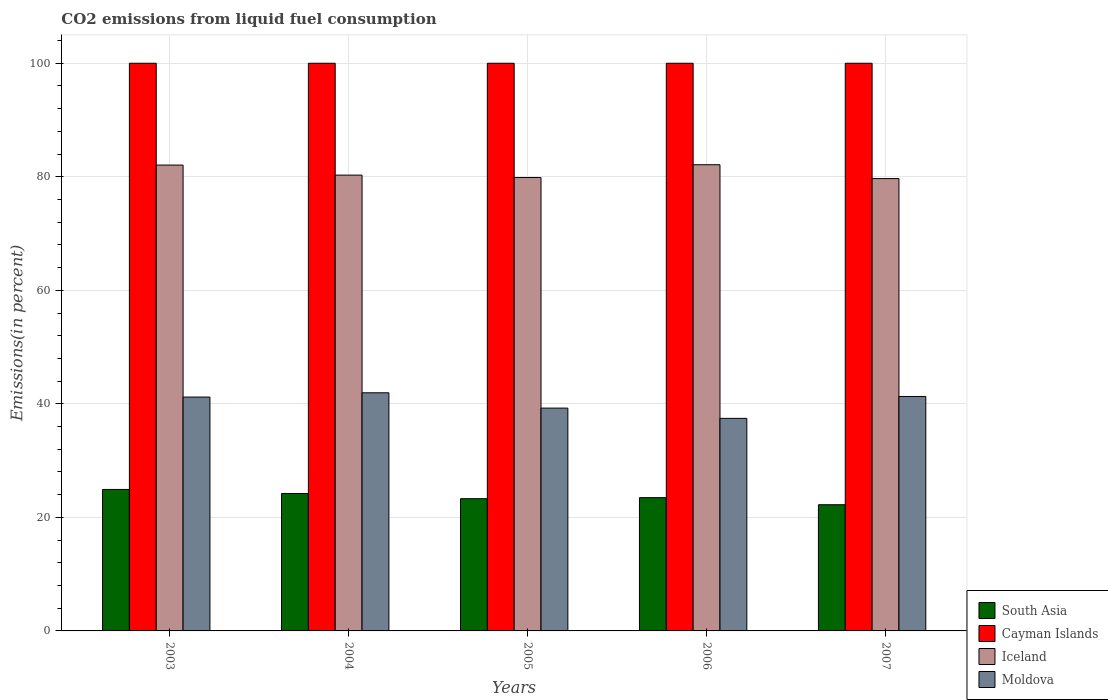Are the number of bars per tick equal to the number of legend labels?
Offer a very short reply. Yes. Are the number of bars on each tick of the X-axis equal?
Make the answer very short. Yes. How many bars are there on the 5th tick from the right?
Offer a terse response. 4. What is the label of the 2nd group of bars from the left?
Provide a short and direct response. 2004. In how many cases, is the number of bars for a given year not equal to the number of legend labels?
Ensure brevity in your answer.  0. What is the total CO2 emitted in South Asia in 2007?
Give a very brief answer. 22.23. Across all years, what is the maximum total CO2 emitted in South Asia?
Provide a short and direct response. 24.92. Across all years, what is the minimum total CO2 emitted in Iceland?
Provide a short and direct response. 79.68. In which year was the total CO2 emitted in Iceland minimum?
Provide a succinct answer. 2007. What is the total total CO2 emitted in Cayman Islands in the graph?
Your answer should be compact. 500. What is the difference between the total CO2 emitted in Moldova in 2005 and that in 2006?
Provide a succinct answer. 1.81. What is the difference between the total CO2 emitted in South Asia in 2005 and the total CO2 emitted in Cayman Islands in 2006?
Provide a succinct answer. -76.71. What is the average total CO2 emitted in Iceland per year?
Your response must be concise. 80.81. In the year 2003, what is the difference between the total CO2 emitted in South Asia and total CO2 emitted in Moldova?
Provide a short and direct response. -16.27. In how many years, is the total CO2 emitted in Iceland greater than 32 %?
Give a very brief answer. 5. What is the ratio of the total CO2 emitted in Moldova in 2003 to that in 2004?
Give a very brief answer. 0.98. What is the difference between the highest and the second highest total CO2 emitted in Moldova?
Ensure brevity in your answer.  0.65. What is the difference between the highest and the lowest total CO2 emitted in Iceland?
Your response must be concise. 2.44. In how many years, is the total CO2 emitted in South Asia greater than the average total CO2 emitted in South Asia taken over all years?
Your answer should be very brief. 2. What does the 3rd bar from the left in 2003 represents?
Your answer should be very brief. Iceland. Is it the case that in every year, the sum of the total CO2 emitted in Moldova and total CO2 emitted in South Asia is greater than the total CO2 emitted in Iceland?
Ensure brevity in your answer.  No. How many bars are there?
Your answer should be compact. 20. Are all the bars in the graph horizontal?
Offer a very short reply. No. What is the difference between two consecutive major ticks on the Y-axis?
Your answer should be very brief. 20. Are the values on the major ticks of Y-axis written in scientific E-notation?
Your response must be concise. No. Where does the legend appear in the graph?
Your answer should be very brief. Bottom right. What is the title of the graph?
Your answer should be compact. CO2 emissions from liquid fuel consumption. Does "Congo (Republic)" appear as one of the legend labels in the graph?
Ensure brevity in your answer.  No. What is the label or title of the Y-axis?
Provide a succinct answer. Emissions(in percent). What is the Emissions(in percent) in South Asia in 2003?
Provide a succinct answer. 24.92. What is the Emissions(in percent) in Cayman Islands in 2003?
Offer a terse response. 100. What is the Emissions(in percent) in Iceland in 2003?
Your answer should be very brief. 82.06. What is the Emissions(in percent) of Moldova in 2003?
Your response must be concise. 41.2. What is the Emissions(in percent) in South Asia in 2004?
Offer a terse response. 24.21. What is the Emissions(in percent) of Cayman Islands in 2004?
Your answer should be very brief. 100. What is the Emissions(in percent) in Iceland in 2004?
Offer a terse response. 80.3. What is the Emissions(in percent) in Moldova in 2004?
Make the answer very short. 41.95. What is the Emissions(in percent) in South Asia in 2005?
Your response must be concise. 23.29. What is the Emissions(in percent) of Iceland in 2005?
Ensure brevity in your answer.  79.87. What is the Emissions(in percent) in Moldova in 2005?
Ensure brevity in your answer.  39.25. What is the Emissions(in percent) of South Asia in 2006?
Provide a succinct answer. 23.48. What is the Emissions(in percent) in Cayman Islands in 2006?
Make the answer very short. 100. What is the Emissions(in percent) in Iceland in 2006?
Make the answer very short. 82.13. What is the Emissions(in percent) in Moldova in 2006?
Your response must be concise. 37.44. What is the Emissions(in percent) in South Asia in 2007?
Offer a terse response. 22.23. What is the Emissions(in percent) in Iceland in 2007?
Make the answer very short. 79.68. What is the Emissions(in percent) in Moldova in 2007?
Keep it short and to the point. 41.3. Across all years, what is the maximum Emissions(in percent) in South Asia?
Ensure brevity in your answer.  24.92. Across all years, what is the maximum Emissions(in percent) of Cayman Islands?
Provide a short and direct response. 100. Across all years, what is the maximum Emissions(in percent) of Iceland?
Offer a very short reply. 82.13. Across all years, what is the maximum Emissions(in percent) of Moldova?
Give a very brief answer. 41.95. Across all years, what is the minimum Emissions(in percent) of South Asia?
Make the answer very short. 22.23. Across all years, what is the minimum Emissions(in percent) of Iceland?
Give a very brief answer. 79.68. Across all years, what is the minimum Emissions(in percent) in Moldova?
Your answer should be compact. 37.44. What is the total Emissions(in percent) in South Asia in the graph?
Provide a succinct answer. 118.14. What is the total Emissions(in percent) of Cayman Islands in the graph?
Ensure brevity in your answer.  500. What is the total Emissions(in percent) of Iceland in the graph?
Provide a short and direct response. 404.03. What is the total Emissions(in percent) in Moldova in the graph?
Make the answer very short. 201.14. What is the difference between the Emissions(in percent) in South Asia in 2003 and that in 2004?
Make the answer very short. 0.71. What is the difference between the Emissions(in percent) in Iceland in 2003 and that in 2004?
Provide a short and direct response. 1.77. What is the difference between the Emissions(in percent) of Moldova in 2003 and that in 2004?
Your response must be concise. -0.75. What is the difference between the Emissions(in percent) in South Asia in 2003 and that in 2005?
Keep it short and to the point. 1.63. What is the difference between the Emissions(in percent) in Cayman Islands in 2003 and that in 2005?
Keep it short and to the point. 0. What is the difference between the Emissions(in percent) in Iceland in 2003 and that in 2005?
Offer a terse response. 2.2. What is the difference between the Emissions(in percent) of Moldova in 2003 and that in 2005?
Offer a very short reply. 1.95. What is the difference between the Emissions(in percent) in South Asia in 2003 and that in 2006?
Keep it short and to the point. 1.44. What is the difference between the Emissions(in percent) of Iceland in 2003 and that in 2006?
Offer a terse response. -0.06. What is the difference between the Emissions(in percent) in Moldova in 2003 and that in 2006?
Your response must be concise. 3.75. What is the difference between the Emissions(in percent) in South Asia in 2003 and that in 2007?
Provide a short and direct response. 2.69. What is the difference between the Emissions(in percent) of Iceland in 2003 and that in 2007?
Give a very brief answer. 2.38. What is the difference between the Emissions(in percent) of Moldova in 2003 and that in 2007?
Make the answer very short. -0.1. What is the difference between the Emissions(in percent) of South Asia in 2004 and that in 2005?
Provide a succinct answer. 0.92. What is the difference between the Emissions(in percent) in Cayman Islands in 2004 and that in 2005?
Offer a very short reply. 0. What is the difference between the Emissions(in percent) in Iceland in 2004 and that in 2005?
Provide a short and direct response. 0.43. What is the difference between the Emissions(in percent) of Moldova in 2004 and that in 2005?
Provide a short and direct response. 2.7. What is the difference between the Emissions(in percent) of South Asia in 2004 and that in 2006?
Your response must be concise. 0.73. What is the difference between the Emissions(in percent) in Cayman Islands in 2004 and that in 2006?
Keep it short and to the point. 0. What is the difference between the Emissions(in percent) in Iceland in 2004 and that in 2006?
Make the answer very short. -1.83. What is the difference between the Emissions(in percent) of Moldova in 2004 and that in 2006?
Your response must be concise. 4.5. What is the difference between the Emissions(in percent) of South Asia in 2004 and that in 2007?
Keep it short and to the point. 1.98. What is the difference between the Emissions(in percent) of Iceland in 2004 and that in 2007?
Give a very brief answer. 0.61. What is the difference between the Emissions(in percent) of Moldova in 2004 and that in 2007?
Your response must be concise. 0.65. What is the difference between the Emissions(in percent) in South Asia in 2005 and that in 2006?
Provide a short and direct response. -0.18. What is the difference between the Emissions(in percent) of Iceland in 2005 and that in 2006?
Provide a succinct answer. -2.26. What is the difference between the Emissions(in percent) of Moldova in 2005 and that in 2006?
Make the answer very short. 1.81. What is the difference between the Emissions(in percent) in South Asia in 2005 and that in 2007?
Provide a succinct answer. 1.06. What is the difference between the Emissions(in percent) in Cayman Islands in 2005 and that in 2007?
Make the answer very short. 0. What is the difference between the Emissions(in percent) of Iceland in 2005 and that in 2007?
Your answer should be compact. 0.18. What is the difference between the Emissions(in percent) of Moldova in 2005 and that in 2007?
Your answer should be compact. -2.05. What is the difference between the Emissions(in percent) in South Asia in 2006 and that in 2007?
Offer a very short reply. 1.25. What is the difference between the Emissions(in percent) of Iceland in 2006 and that in 2007?
Keep it short and to the point. 2.44. What is the difference between the Emissions(in percent) in Moldova in 2006 and that in 2007?
Your answer should be compact. -3.86. What is the difference between the Emissions(in percent) of South Asia in 2003 and the Emissions(in percent) of Cayman Islands in 2004?
Your response must be concise. -75.08. What is the difference between the Emissions(in percent) of South Asia in 2003 and the Emissions(in percent) of Iceland in 2004?
Offer a terse response. -55.37. What is the difference between the Emissions(in percent) in South Asia in 2003 and the Emissions(in percent) in Moldova in 2004?
Make the answer very short. -17.03. What is the difference between the Emissions(in percent) of Cayman Islands in 2003 and the Emissions(in percent) of Iceland in 2004?
Give a very brief answer. 19.7. What is the difference between the Emissions(in percent) of Cayman Islands in 2003 and the Emissions(in percent) of Moldova in 2004?
Your answer should be very brief. 58.05. What is the difference between the Emissions(in percent) of Iceland in 2003 and the Emissions(in percent) of Moldova in 2004?
Provide a succinct answer. 40.12. What is the difference between the Emissions(in percent) in South Asia in 2003 and the Emissions(in percent) in Cayman Islands in 2005?
Give a very brief answer. -75.08. What is the difference between the Emissions(in percent) of South Asia in 2003 and the Emissions(in percent) of Iceland in 2005?
Keep it short and to the point. -54.94. What is the difference between the Emissions(in percent) in South Asia in 2003 and the Emissions(in percent) in Moldova in 2005?
Provide a succinct answer. -14.33. What is the difference between the Emissions(in percent) in Cayman Islands in 2003 and the Emissions(in percent) in Iceland in 2005?
Offer a terse response. 20.13. What is the difference between the Emissions(in percent) of Cayman Islands in 2003 and the Emissions(in percent) of Moldova in 2005?
Your answer should be compact. 60.75. What is the difference between the Emissions(in percent) in Iceland in 2003 and the Emissions(in percent) in Moldova in 2005?
Provide a succinct answer. 42.81. What is the difference between the Emissions(in percent) in South Asia in 2003 and the Emissions(in percent) in Cayman Islands in 2006?
Ensure brevity in your answer.  -75.08. What is the difference between the Emissions(in percent) in South Asia in 2003 and the Emissions(in percent) in Iceland in 2006?
Ensure brevity in your answer.  -57.2. What is the difference between the Emissions(in percent) of South Asia in 2003 and the Emissions(in percent) of Moldova in 2006?
Your answer should be compact. -12.52. What is the difference between the Emissions(in percent) in Cayman Islands in 2003 and the Emissions(in percent) in Iceland in 2006?
Your answer should be compact. 17.87. What is the difference between the Emissions(in percent) in Cayman Islands in 2003 and the Emissions(in percent) in Moldova in 2006?
Offer a terse response. 62.56. What is the difference between the Emissions(in percent) in Iceland in 2003 and the Emissions(in percent) in Moldova in 2006?
Ensure brevity in your answer.  44.62. What is the difference between the Emissions(in percent) of South Asia in 2003 and the Emissions(in percent) of Cayman Islands in 2007?
Your answer should be very brief. -75.08. What is the difference between the Emissions(in percent) of South Asia in 2003 and the Emissions(in percent) of Iceland in 2007?
Offer a very short reply. -54.76. What is the difference between the Emissions(in percent) in South Asia in 2003 and the Emissions(in percent) in Moldova in 2007?
Offer a terse response. -16.38. What is the difference between the Emissions(in percent) of Cayman Islands in 2003 and the Emissions(in percent) of Iceland in 2007?
Your response must be concise. 20.32. What is the difference between the Emissions(in percent) of Cayman Islands in 2003 and the Emissions(in percent) of Moldova in 2007?
Your response must be concise. 58.7. What is the difference between the Emissions(in percent) of Iceland in 2003 and the Emissions(in percent) of Moldova in 2007?
Your response must be concise. 40.76. What is the difference between the Emissions(in percent) of South Asia in 2004 and the Emissions(in percent) of Cayman Islands in 2005?
Offer a very short reply. -75.79. What is the difference between the Emissions(in percent) in South Asia in 2004 and the Emissions(in percent) in Iceland in 2005?
Ensure brevity in your answer.  -55.65. What is the difference between the Emissions(in percent) of South Asia in 2004 and the Emissions(in percent) of Moldova in 2005?
Provide a short and direct response. -15.04. What is the difference between the Emissions(in percent) of Cayman Islands in 2004 and the Emissions(in percent) of Iceland in 2005?
Offer a terse response. 20.13. What is the difference between the Emissions(in percent) of Cayman Islands in 2004 and the Emissions(in percent) of Moldova in 2005?
Offer a terse response. 60.75. What is the difference between the Emissions(in percent) in Iceland in 2004 and the Emissions(in percent) in Moldova in 2005?
Your answer should be compact. 41.04. What is the difference between the Emissions(in percent) of South Asia in 2004 and the Emissions(in percent) of Cayman Islands in 2006?
Provide a succinct answer. -75.79. What is the difference between the Emissions(in percent) in South Asia in 2004 and the Emissions(in percent) in Iceland in 2006?
Provide a short and direct response. -57.91. What is the difference between the Emissions(in percent) of South Asia in 2004 and the Emissions(in percent) of Moldova in 2006?
Provide a short and direct response. -13.23. What is the difference between the Emissions(in percent) in Cayman Islands in 2004 and the Emissions(in percent) in Iceland in 2006?
Provide a succinct answer. 17.87. What is the difference between the Emissions(in percent) of Cayman Islands in 2004 and the Emissions(in percent) of Moldova in 2006?
Keep it short and to the point. 62.56. What is the difference between the Emissions(in percent) in Iceland in 2004 and the Emissions(in percent) in Moldova in 2006?
Give a very brief answer. 42.85. What is the difference between the Emissions(in percent) in South Asia in 2004 and the Emissions(in percent) in Cayman Islands in 2007?
Your answer should be very brief. -75.79. What is the difference between the Emissions(in percent) in South Asia in 2004 and the Emissions(in percent) in Iceland in 2007?
Offer a terse response. -55.47. What is the difference between the Emissions(in percent) of South Asia in 2004 and the Emissions(in percent) of Moldova in 2007?
Make the answer very short. -17.09. What is the difference between the Emissions(in percent) of Cayman Islands in 2004 and the Emissions(in percent) of Iceland in 2007?
Ensure brevity in your answer.  20.32. What is the difference between the Emissions(in percent) of Cayman Islands in 2004 and the Emissions(in percent) of Moldova in 2007?
Provide a short and direct response. 58.7. What is the difference between the Emissions(in percent) in Iceland in 2004 and the Emissions(in percent) in Moldova in 2007?
Your answer should be very brief. 38.99. What is the difference between the Emissions(in percent) of South Asia in 2005 and the Emissions(in percent) of Cayman Islands in 2006?
Give a very brief answer. -76.71. What is the difference between the Emissions(in percent) in South Asia in 2005 and the Emissions(in percent) in Iceland in 2006?
Offer a very short reply. -58.83. What is the difference between the Emissions(in percent) of South Asia in 2005 and the Emissions(in percent) of Moldova in 2006?
Offer a very short reply. -14.15. What is the difference between the Emissions(in percent) in Cayman Islands in 2005 and the Emissions(in percent) in Iceland in 2006?
Ensure brevity in your answer.  17.87. What is the difference between the Emissions(in percent) of Cayman Islands in 2005 and the Emissions(in percent) of Moldova in 2006?
Give a very brief answer. 62.56. What is the difference between the Emissions(in percent) in Iceland in 2005 and the Emissions(in percent) in Moldova in 2006?
Make the answer very short. 42.42. What is the difference between the Emissions(in percent) of South Asia in 2005 and the Emissions(in percent) of Cayman Islands in 2007?
Ensure brevity in your answer.  -76.71. What is the difference between the Emissions(in percent) in South Asia in 2005 and the Emissions(in percent) in Iceland in 2007?
Offer a terse response. -56.39. What is the difference between the Emissions(in percent) of South Asia in 2005 and the Emissions(in percent) of Moldova in 2007?
Keep it short and to the point. -18.01. What is the difference between the Emissions(in percent) in Cayman Islands in 2005 and the Emissions(in percent) in Iceland in 2007?
Keep it short and to the point. 20.32. What is the difference between the Emissions(in percent) of Cayman Islands in 2005 and the Emissions(in percent) of Moldova in 2007?
Your answer should be very brief. 58.7. What is the difference between the Emissions(in percent) in Iceland in 2005 and the Emissions(in percent) in Moldova in 2007?
Your answer should be compact. 38.57. What is the difference between the Emissions(in percent) of South Asia in 2006 and the Emissions(in percent) of Cayman Islands in 2007?
Your response must be concise. -76.52. What is the difference between the Emissions(in percent) in South Asia in 2006 and the Emissions(in percent) in Iceland in 2007?
Provide a short and direct response. -56.2. What is the difference between the Emissions(in percent) in South Asia in 2006 and the Emissions(in percent) in Moldova in 2007?
Your answer should be very brief. -17.82. What is the difference between the Emissions(in percent) of Cayman Islands in 2006 and the Emissions(in percent) of Iceland in 2007?
Keep it short and to the point. 20.32. What is the difference between the Emissions(in percent) of Cayman Islands in 2006 and the Emissions(in percent) of Moldova in 2007?
Offer a very short reply. 58.7. What is the difference between the Emissions(in percent) of Iceland in 2006 and the Emissions(in percent) of Moldova in 2007?
Your answer should be compact. 40.82. What is the average Emissions(in percent) in South Asia per year?
Make the answer very short. 23.63. What is the average Emissions(in percent) in Iceland per year?
Offer a terse response. 80.81. What is the average Emissions(in percent) of Moldova per year?
Your answer should be very brief. 40.23. In the year 2003, what is the difference between the Emissions(in percent) of South Asia and Emissions(in percent) of Cayman Islands?
Provide a short and direct response. -75.08. In the year 2003, what is the difference between the Emissions(in percent) of South Asia and Emissions(in percent) of Iceland?
Your response must be concise. -57.14. In the year 2003, what is the difference between the Emissions(in percent) of South Asia and Emissions(in percent) of Moldova?
Offer a very short reply. -16.27. In the year 2003, what is the difference between the Emissions(in percent) in Cayman Islands and Emissions(in percent) in Iceland?
Offer a very short reply. 17.94. In the year 2003, what is the difference between the Emissions(in percent) in Cayman Islands and Emissions(in percent) in Moldova?
Give a very brief answer. 58.8. In the year 2003, what is the difference between the Emissions(in percent) in Iceland and Emissions(in percent) in Moldova?
Make the answer very short. 40.87. In the year 2004, what is the difference between the Emissions(in percent) of South Asia and Emissions(in percent) of Cayman Islands?
Provide a succinct answer. -75.79. In the year 2004, what is the difference between the Emissions(in percent) in South Asia and Emissions(in percent) in Iceland?
Ensure brevity in your answer.  -56.08. In the year 2004, what is the difference between the Emissions(in percent) in South Asia and Emissions(in percent) in Moldova?
Keep it short and to the point. -17.74. In the year 2004, what is the difference between the Emissions(in percent) in Cayman Islands and Emissions(in percent) in Iceland?
Provide a succinct answer. 19.7. In the year 2004, what is the difference between the Emissions(in percent) of Cayman Islands and Emissions(in percent) of Moldova?
Your answer should be very brief. 58.05. In the year 2004, what is the difference between the Emissions(in percent) of Iceland and Emissions(in percent) of Moldova?
Provide a succinct answer. 38.35. In the year 2005, what is the difference between the Emissions(in percent) of South Asia and Emissions(in percent) of Cayman Islands?
Your answer should be compact. -76.71. In the year 2005, what is the difference between the Emissions(in percent) in South Asia and Emissions(in percent) in Iceland?
Your answer should be very brief. -56.57. In the year 2005, what is the difference between the Emissions(in percent) of South Asia and Emissions(in percent) of Moldova?
Your answer should be very brief. -15.96. In the year 2005, what is the difference between the Emissions(in percent) of Cayman Islands and Emissions(in percent) of Iceland?
Your response must be concise. 20.13. In the year 2005, what is the difference between the Emissions(in percent) of Cayman Islands and Emissions(in percent) of Moldova?
Your answer should be compact. 60.75. In the year 2005, what is the difference between the Emissions(in percent) of Iceland and Emissions(in percent) of Moldova?
Keep it short and to the point. 40.62. In the year 2006, what is the difference between the Emissions(in percent) of South Asia and Emissions(in percent) of Cayman Islands?
Offer a very short reply. -76.52. In the year 2006, what is the difference between the Emissions(in percent) of South Asia and Emissions(in percent) of Iceland?
Provide a succinct answer. -58.65. In the year 2006, what is the difference between the Emissions(in percent) in South Asia and Emissions(in percent) in Moldova?
Provide a succinct answer. -13.97. In the year 2006, what is the difference between the Emissions(in percent) in Cayman Islands and Emissions(in percent) in Iceland?
Provide a short and direct response. 17.87. In the year 2006, what is the difference between the Emissions(in percent) of Cayman Islands and Emissions(in percent) of Moldova?
Your response must be concise. 62.56. In the year 2006, what is the difference between the Emissions(in percent) of Iceland and Emissions(in percent) of Moldova?
Make the answer very short. 44.68. In the year 2007, what is the difference between the Emissions(in percent) of South Asia and Emissions(in percent) of Cayman Islands?
Provide a succinct answer. -77.77. In the year 2007, what is the difference between the Emissions(in percent) of South Asia and Emissions(in percent) of Iceland?
Offer a very short reply. -57.45. In the year 2007, what is the difference between the Emissions(in percent) in South Asia and Emissions(in percent) in Moldova?
Keep it short and to the point. -19.07. In the year 2007, what is the difference between the Emissions(in percent) in Cayman Islands and Emissions(in percent) in Iceland?
Give a very brief answer. 20.32. In the year 2007, what is the difference between the Emissions(in percent) of Cayman Islands and Emissions(in percent) of Moldova?
Provide a short and direct response. 58.7. In the year 2007, what is the difference between the Emissions(in percent) in Iceland and Emissions(in percent) in Moldova?
Your answer should be compact. 38.38. What is the ratio of the Emissions(in percent) of South Asia in 2003 to that in 2004?
Your answer should be very brief. 1.03. What is the ratio of the Emissions(in percent) of Iceland in 2003 to that in 2004?
Your answer should be compact. 1.02. What is the ratio of the Emissions(in percent) of Moldova in 2003 to that in 2004?
Keep it short and to the point. 0.98. What is the ratio of the Emissions(in percent) in South Asia in 2003 to that in 2005?
Ensure brevity in your answer.  1.07. What is the ratio of the Emissions(in percent) in Iceland in 2003 to that in 2005?
Your answer should be very brief. 1.03. What is the ratio of the Emissions(in percent) of Moldova in 2003 to that in 2005?
Keep it short and to the point. 1.05. What is the ratio of the Emissions(in percent) of South Asia in 2003 to that in 2006?
Provide a succinct answer. 1.06. What is the ratio of the Emissions(in percent) of Cayman Islands in 2003 to that in 2006?
Your response must be concise. 1. What is the ratio of the Emissions(in percent) in Moldova in 2003 to that in 2006?
Make the answer very short. 1.1. What is the ratio of the Emissions(in percent) of South Asia in 2003 to that in 2007?
Offer a very short reply. 1.12. What is the ratio of the Emissions(in percent) of Cayman Islands in 2003 to that in 2007?
Ensure brevity in your answer.  1. What is the ratio of the Emissions(in percent) of Iceland in 2003 to that in 2007?
Your answer should be very brief. 1.03. What is the ratio of the Emissions(in percent) of South Asia in 2004 to that in 2005?
Ensure brevity in your answer.  1.04. What is the ratio of the Emissions(in percent) of Iceland in 2004 to that in 2005?
Give a very brief answer. 1.01. What is the ratio of the Emissions(in percent) in Moldova in 2004 to that in 2005?
Give a very brief answer. 1.07. What is the ratio of the Emissions(in percent) of South Asia in 2004 to that in 2006?
Ensure brevity in your answer.  1.03. What is the ratio of the Emissions(in percent) in Cayman Islands in 2004 to that in 2006?
Provide a succinct answer. 1. What is the ratio of the Emissions(in percent) in Iceland in 2004 to that in 2006?
Offer a terse response. 0.98. What is the ratio of the Emissions(in percent) of Moldova in 2004 to that in 2006?
Offer a very short reply. 1.12. What is the ratio of the Emissions(in percent) in South Asia in 2004 to that in 2007?
Your response must be concise. 1.09. What is the ratio of the Emissions(in percent) of Iceland in 2004 to that in 2007?
Your response must be concise. 1.01. What is the ratio of the Emissions(in percent) in Moldova in 2004 to that in 2007?
Ensure brevity in your answer.  1.02. What is the ratio of the Emissions(in percent) of Iceland in 2005 to that in 2006?
Keep it short and to the point. 0.97. What is the ratio of the Emissions(in percent) of Moldova in 2005 to that in 2006?
Provide a succinct answer. 1.05. What is the ratio of the Emissions(in percent) in South Asia in 2005 to that in 2007?
Give a very brief answer. 1.05. What is the ratio of the Emissions(in percent) of Moldova in 2005 to that in 2007?
Provide a short and direct response. 0.95. What is the ratio of the Emissions(in percent) in South Asia in 2006 to that in 2007?
Make the answer very short. 1.06. What is the ratio of the Emissions(in percent) in Iceland in 2006 to that in 2007?
Provide a succinct answer. 1.03. What is the ratio of the Emissions(in percent) in Moldova in 2006 to that in 2007?
Your answer should be compact. 0.91. What is the difference between the highest and the second highest Emissions(in percent) in South Asia?
Give a very brief answer. 0.71. What is the difference between the highest and the second highest Emissions(in percent) of Cayman Islands?
Provide a succinct answer. 0. What is the difference between the highest and the second highest Emissions(in percent) in Iceland?
Keep it short and to the point. 0.06. What is the difference between the highest and the second highest Emissions(in percent) of Moldova?
Your answer should be very brief. 0.65. What is the difference between the highest and the lowest Emissions(in percent) of South Asia?
Your answer should be compact. 2.69. What is the difference between the highest and the lowest Emissions(in percent) of Cayman Islands?
Provide a succinct answer. 0. What is the difference between the highest and the lowest Emissions(in percent) of Iceland?
Provide a short and direct response. 2.44. What is the difference between the highest and the lowest Emissions(in percent) of Moldova?
Ensure brevity in your answer.  4.5. 